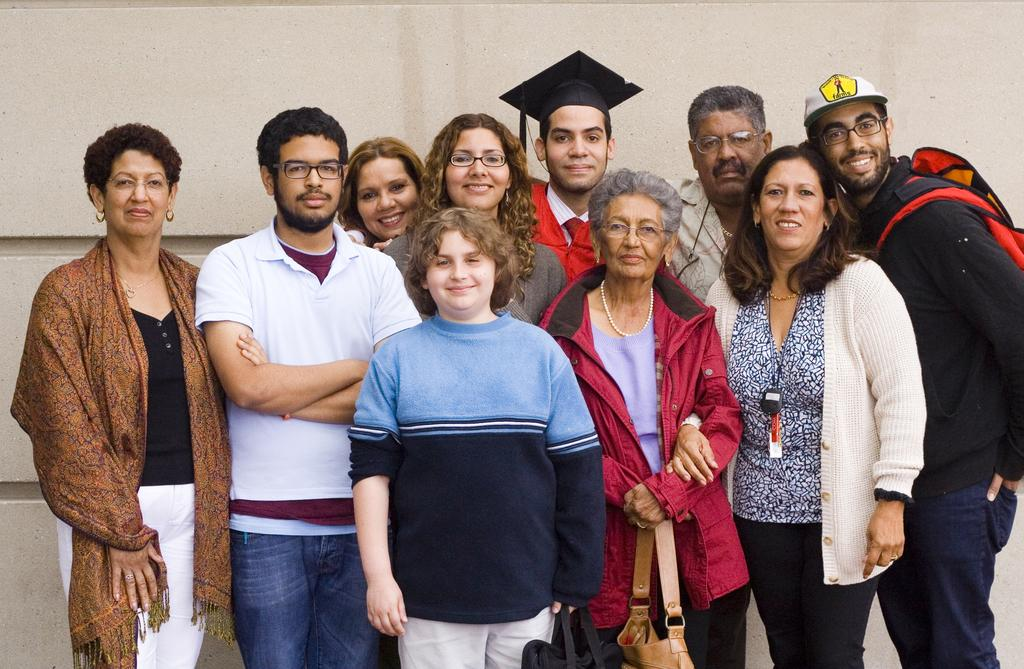What is happening in the foreground of the image? There are people standing in the foreground of the image. What are the people doing in the image? The people are posing for a camera. What can be seen in the background of the image? There is a wall in the background of the image. What type of education can be seen in the image? There is no indication of education in the image; it features people posing for a camera in front of a wall. How many stars are visible in the image? There are no stars visible in the image; it is set against a wall in the background. 